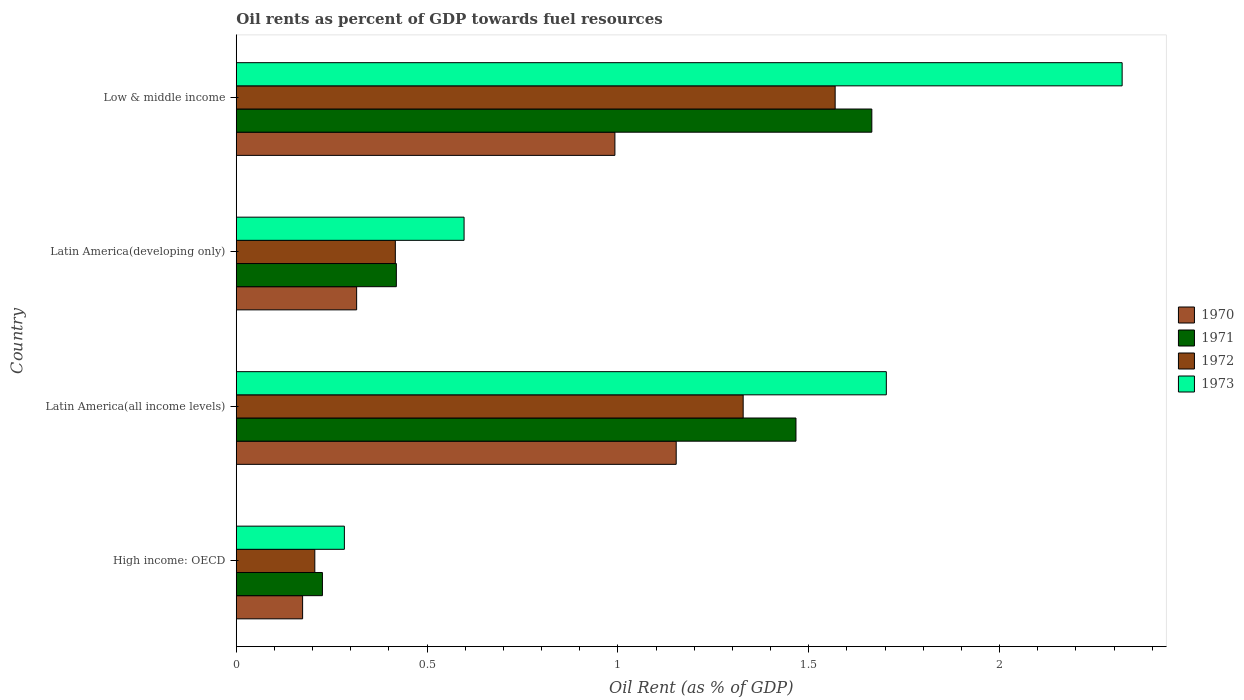How many different coloured bars are there?
Your answer should be very brief. 4. In how many cases, is the number of bars for a given country not equal to the number of legend labels?
Your answer should be very brief. 0. What is the oil rent in 1973 in Latin America(developing only)?
Offer a very short reply. 0.6. Across all countries, what is the maximum oil rent in 1971?
Your answer should be very brief. 1.67. Across all countries, what is the minimum oil rent in 1971?
Provide a succinct answer. 0.23. In which country was the oil rent in 1972 maximum?
Your answer should be compact. Low & middle income. In which country was the oil rent in 1973 minimum?
Ensure brevity in your answer.  High income: OECD. What is the total oil rent in 1972 in the graph?
Offer a very short reply. 3.52. What is the difference between the oil rent in 1972 in Latin America(all income levels) and that in Low & middle income?
Offer a very short reply. -0.24. What is the difference between the oil rent in 1972 in Latin America(all income levels) and the oil rent in 1971 in High income: OECD?
Make the answer very short. 1.1. What is the average oil rent in 1972 per country?
Offer a very short reply. 0.88. What is the difference between the oil rent in 1970 and oil rent in 1972 in Latin America(developing only)?
Make the answer very short. -0.1. In how many countries, is the oil rent in 1972 greater than 0.30000000000000004 %?
Ensure brevity in your answer.  3. What is the ratio of the oil rent in 1971 in High income: OECD to that in Low & middle income?
Provide a succinct answer. 0.14. What is the difference between the highest and the second highest oil rent in 1970?
Your response must be concise. 0.16. What is the difference between the highest and the lowest oil rent in 1970?
Your answer should be compact. 0.98. Is it the case that in every country, the sum of the oil rent in 1973 and oil rent in 1971 is greater than the sum of oil rent in 1970 and oil rent in 1972?
Provide a short and direct response. No. What does the 3rd bar from the top in Low & middle income represents?
Keep it short and to the point. 1971. Is it the case that in every country, the sum of the oil rent in 1971 and oil rent in 1970 is greater than the oil rent in 1973?
Keep it short and to the point. Yes. How many bars are there?
Ensure brevity in your answer.  16. What is the difference between two consecutive major ticks on the X-axis?
Offer a terse response. 0.5. Are the values on the major ticks of X-axis written in scientific E-notation?
Offer a terse response. No. Does the graph contain grids?
Provide a short and direct response. No. How many legend labels are there?
Provide a short and direct response. 4. What is the title of the graph?
Make the answer very short. Oil rents as percent of GDP towards fuel resources. What is the label or title of the X-axis?
Offer a very short reply. Oil Rent (as % of GDP). What is the label or title of the Y-axis?
Your answer should be compact. Country. What is the Oil Rent (as % of GDP) in 1970 in High income: OECD?
Keep it short and to the point. 0.17. What is the Oil Rent (as % of GDP) of 1971 in High income: OECD?
Your response must be concise. 0.23. What is the Oil Rent (as % of GDP) in 1972 in High income: OECD?
Offer a terse response. 0.21. What is the Oil Rent (as % of GDP) in 1973 in High income: OECD?
Provide a short and direct response. 0.28. What is the Oil Rent (as % of GDP) of 1970 in Latin America(all income levels)?
Your answer should be compact. 1.15. What is the Oil Rent (as % of GDP) of 1971 in Latin America(all income levels)?
Ensure brevity in your answer.  1.47. What is the Oil Rent (as % of GDP) of 1972 in Latin America(all income levels)?
Provide a short and direct response. 1.33. What is the Oil Rent (as % of GDP) in 1973 in Latin America(all income levels)?
Provide a succinct answer. 1.7. What is the Oil Rent (as % of GDP) in 1970 in Latin America(developing only)?
Ensure brevity in your answer.  0.32. What is the Oil Rent (as % of GDP) in 1971 in Latin America(developing only)?
Make the answer very short. 0.42. What is the Oil Rent (as % of GDP) in 1972 in Latin America(developing only)?
Your response must be concise. 0.42. What is the Oil Rent (as % of GDP) in 1973 in Latin America(developing only)?
Provide a succinct answer. 0.6. What is the Oil Rent (as % of GDP) in 1970 in Low & middle income?
Give a very brief answer. 0.99. What is the Oil Rent (as % of GDP) in 1971 in Low & middle income?
Offer a terse response. 1.67. What is the Oil Rent (as % of GDP) of 1972 in Low & middle income?
Offer a terse response. 1.57. What is the Oil Rent (as % of GDP) in 1973 in Low & middle income?
Offer a terse response. 2.32. Across all countries, what is the maximum Oil Rent (as % of GDP) of 1970?
Your answer should be very brief. 1.15. Across all countries, what is the maximum Oil Rent (as % of GDP) of 1971?
Offer a very short reply. 1.67. Across all countries, what is the maximum Oil Rent (as % of GDP) of 1972?
Your answer should be compact. 1.57. Across all countries, what is the maximum Oil Rent (as % of GDP) in 1973?
Provide a succinct answer. 2.32. Across all countries, what is the minimum Oil Rent (as % of GDP) in 1970?
Provide a short and direct response. 0.17. Across all countries, what is the minimum Oil Rent (as % of GDP) of 1971?
Offer a terse response. 0.23. Across all countries, what is the minimum Oil Rent (as % of GDP) in 1972?
Your answer should be very brief. 0.21. Across all countries, what is the minimum Oil Rent (as % of GDP) of 1973?
Keep it short and to the point. 0.28. What is the total Oil Rent (as % of GDP) of 1970 in the graph?
Make the answer very short. 2.63. What is the total Oil Rent (as % of GDP) in 1971 in the graph?
Give a very brief answer. 3.78. What is the total Oil Rent (as % of GDP) in 1972 in the graph?
Your answer should be very brief. 3.52. What is the total Oil Rent (as % of GDP) in 1973 in the graph?
Ensure brevity in your answer.  4.9. What is the difference between the Oil Rent (as % of GDP) of 1970 in High income: OECD and that in Latin America(all income levels)?
Offer a terse response. -0.98. What is the difference between the Oil Rent (as % of GDP) of 1971 in High income: OECD and that in Latin America(all income levels)?
Keep it short and to the point. -1.24. What is the difference between the Oil Rent (as % of GDP) of 1972 in High income: OECD and that in Latin America(all income levels)?
Offer a terse response. -1.12. What is the difference between the Oil Rent (as % of GDP) of 1973 in High income: OECD and that in Latin America(all income levels)?
Your answer should be very brief. -1.42. What is the difference between the Oil Rent (as % of GDP) of 1970 in High income: OECD and that in Latin America(developing only)?
Keep it short and to the point. -0.14. What is the difference between the Oil Rent (as % of GDP) in 1971 in High income: OECD and that in Latin America(developing only)?
Ensure brevity in your answer.  -0.19. What is the difference between the Oil Rent (as % of GDP) in 1972 in High income: OECD and that in Latin America(developing only)?
Offer a very short reply. -0.21. What is the difference between the Oil Rent (as % of GDP) in 1973 in High income: OECD and that in Latin America(developing only)?
Provide a succinct answer. -0.31. What is the difference between the Oil Rent (as % of GDP) of 1970 in High income: OECD and that in Low & middle income?
Your answer should be very brief. -0.82. What is the difference between the Oil Rent (as % of GDP) of 1971 in High income: OECD and that in Low & middle income?
Keep it short and to the point. -1.44. What is the difference between the Oil Rent (as % of GDP) in 1972 in High income: OECD and that in Low & middle income?
Provide a succinct answer. -1.36. What is the difference between the Oil Rent (as % of GDP) of 1973 in High income: OECD and that in Low & middle income?
Your response must be concise. -2.04. What is the difference between the Oil Rent (as % of GDP) in 1970 in Latin America(all income levels) and that in Latin America(developing only)?
Offer a very short reply. 0.84. What is the difference between the Oil Rent (as % of GDP) in 1971 in Latin America(all income levels) and that in Latin America(developing only)?
Your answer should be very brief. 1.05. What is the difference between the Oil Rent (as % of GDP) in 1972 in Latin America(all income levels) and that in Latin America(developing only)?
Ensure brevity in your answer.  0.91. What is the difference between the Oil Rent (as % of GDP) in 1973 in Latin America(all income levels) and that in Latin America(developing only)?
Make the answer very short. 1.11. What is the difference between the Oil Rent (as % of GDP) of 1970 in Latin America(all income levels) and that in Low & middle income?
Your answer should be very brief. 0.16. What is the difference between the Oil Rent (as % of GDP) in 1971 in Latin America(all income levels) and that in Low & middle income?
Keep it short and to the point. -0.2. What is the difference between the Oil Rent (as % of GDP) of 1972 in Latin America(all income levels) and that in Low & middle income?
Ensure brevity in your answer.  -0.24. What is the difference between the Oil Rent (as % of GDP) of 1973 in Latin America(all income levels) and that in Low & middle income?
Give a very brief answer. -0.62. What is the difference between the Oil Rent (as % of GDP) of 1970 in Latin America(developing only) and that in Low & middle income?
Make the answer very short. -0.68. What is the difference between the Oil Rent (as % of GDP) in 1971 in Latin America(developing only) and that in Low & middle income?
Offer a terse response. -1.25. What is the difference between the Oil Rent (as % of GDP) of 1972 in Latin America(developing only) and that in Low & middle income?
Your answer should be very brief. -1.15. What is the difference between the Oil Rent (as % of GDP) of 1973 in Latin America(developing only) and that in Low & middle income?
Provide a succinct answer. -1.72. What is the difference between the Oil Rent (as % of GDP) of 1970 in High income: OECD and the Oil Rent (as % of GDP) of 1971 in Latin America(all income levels)?
Keep it short and to the point. -1.29. What is the difference between the Oil Rent (as % of GDP) in 1970 in High income: OECD and the Oil Rent (as % of GDP) in 1972 in Latin America(all income levels)?
Provide a short and direct response. -1.15. What is the difference between the Oil Rent (as % of GDP) of 1970 in High income: OECD and the Oil Rent (as % of GDP) of 1973 in Latin America(all income levels)?
Keep it short and to the point. -1.53. What is the difference between the Oil Rent (as % of GDP) in 1971 in High income: OECD and the Oil Rent (as % of GDP) in 1972 in Latin America(all income levels)?
Your response must be concise. -1.1. What is the difference between the Oil Rent (as % of GDP) in 1971 in High income: OECD and the Oil Rent (as % of GDP) in 1973 in Latin America(all income levels)?
Ensure brevity in your answer.  -1.48. What is the difference between the Oil Rent (as % of GDP) in 1972 in High income: OECD and the Oil Rent (as % of GDP) in 1973 in Latin America(all income levels)?
Give a very brief answer. -1.5. What is the difference between the Oil Rent (as % of GDP) of 1970 in High income: OECD and the Oil Rent (as % of GDP) of 1971 in Latin America(developing only)?
Offer a very short reply. -0.25. What is the difference between the Oil Rent (as % of GDP) in 1970 in High income: OECD and the Oil Rent (as % of GDP) in 1972 in Latin America(developing only)?
Give a very brief answer. -0.24. What is the difference between the Oil Rent (as % of GDP) in 1970 in High income: OECD and the Oil Rent (as % of GDP) in 1973 in Latin America(developing only)?
Make the answer very short. -0.42. What is the difference between the Oil Rent (as % of GDP) in 1971 in High income: OECD and the Oil Rent (as % of GDP) in 1972 in Latin America(developing only)?
Offer a terse response. -0.19. What is the difference between the Oil Rent (as % of GDP) of 1971 in High income: OECD and the Oil Rent (as % of GDP) of 1973 in Latin America(developing only)?
Provide a succinct answer. -0.37. What is the difference between the Oil Rent (as % of GDP) in 1972 in High income: OECD and the Oil Rent (as % of GDP) in 1973 in Latin America(developing only)?
Provide a succinct answer. -0.39. What is the difference between the Oil Rent (as % of GDP) in 1970 in High income: OECD and the Oil Rent (as % of GDP) in 1971 in Low & middle income?
Your answer should be compact. -1.49. What is the difference between the Oil Rent (as % of GDP) of 1970 in High income: OECD and the Oil Rent (as % of GDP) of 1972 in Low & middle income?
Give a very brief answer. -1.4. What is the difference between the Oil Rent (as % of GDP) in 1970 in High income: OECD and the Oil Rent (as % of GDP) in 1973 in Low & middle income?
Ensure brevity in your answer.  -2.15. What is the difference between the Oil Rent (as % of GDP) of 1971 in High income: OECD and the Oil Rent (as % of GDP) of 1972 in Low & middle income?
Your answer should be compact. -1.34. What is the difference between the Oil Rent (as % of GDP) in 1971 in High income: OECD and the Oil Rent (as % of GDP) in 1973 in Low & middle income?
Your answer should be very brief. -2.1. What is the difference between the Oil Rent (as % of GDP) of 1972 in High income: OECD and the Oil Rent (as % of GDP) of 1973 in Low & middle income?
Provide a succinct answer. -2.12. What is the difference between the Oil Rent (as % of GDP) in 1970 in Latin America(all income levels) and the Oil Rent (as % of GDP) in 1971 in Latin America(developing only)?
Keep it short and to the point. 0.73. What is the difference between the Oil Rent (as % of GDP) of 1970 in Latin America(all income levels) and the Oil Rent (as % of GDP) of 1972 in Latin America(developing only)?
Your response must be concise. 0.74. What is the difference between the Oil Rent (as % of GDP) of 1970 in Latin America(all income levels) and the Oil Rent (as % of GDP) of 1973 in Latin America(developing only)?
Provide a short and direct response. 0.56. What is the difference between the Oil Rent (as % of GDP) of 1971 in Latin America(all income levels) and the Oil Rent (as % of GDP) of 1972 in Latin America(developing only)?
Provide a succinct answer. 1.05. What is the difference between the Oil Rent (as % of GDP) in 1971 in Latin America(all income levels) and the Oil Rent (as % of GDP) in 1973 in Latin America(developing only)?
Provide a succinct answer. 0.87. What is the difference between the Oil Rent (as % of GDP) in 1972 in Latin America(all income levels) and the Oil Rent (as % of GDP) in 1973 in Latin America(developing only)?
Your response must be concise. 0.73. What is the difference between the Oil Rent (as % of GDP) in 1970 in Latin America(all income levels) and the Oil Rent (as % of GDP) in 1971 in Low & middle income?
Provide a succinct answer. -0.51. What is the difference between the Oil Rent (as % of GDP) in 1970 in Latin America(all income levels) and the Oil Rent (as % of GDP) in 1972 in Low & middle income?
Offer a terse response. -0.42. What is the difference between the Oil Rent (as % of GDP) of 1970 in Latin America(all income levels) and the Oil Rent (as % of GDP) of 1973 in Low & middle income?
Ensure brevity in your answer.  -1.17. What is the difference between the Oil Rent (as % of GDP) in 1971 in Latin America(all income levels) and the Oil Rent (as % of GDP) in 1972 in Low & middle income?
Ensure brevity in your answer.  -0.1. What is the difference between the Oil Rent (as % of GDP) of 1971 in Latin America(all income levels) and the Oil Rent (as % of GDP) of 1973 in Low & middle income?
Offer a very short reply. -0.85. What is the difference between the Oil Rent (as % of GDP) of 1972 in Latin America(all income levels) and the Oil Rent (as % of GDP) of 1973 in Low & middle income?
Offer a very short reply. -0.99. What is the difference between the Oil Rent (as % of GDP) of 1970 in Latin America(developing only) and the Oil Rent (as % of GDP) of 1971 in Low & middle income?
Make the answer very short. -1.35. What is the difference between the Oil Rent (as % of GDP) of 1970 in Latin America(developing only) and the Oil Rent (as % of GDP) of 1972 in Low & middle income?
Your response must be concise. -1.25. What is the difference between the Oil Rent (as % of GDP) in 1970 in Latin America(developing only) and the Oil Rent (as % of GDP) in 1973 in Low & middle income?
Offer a terse response. -2.01. What is the difference between the Oil Rent (as % of GDP) of 1971 in Latin America(developing only) and the Oil Rent (as % of GDP) of 1972 in Low & middle income?
Provide a succinct answer. -1.15. What is the difference between the Oil Rent (as % of GDP) of 1971 in Latin America(developing only) and the Oil Rent (as % of GDP) of 1973 in Low & middle income?
Your response must be concise. -1.9. What is the difference between the Oil Rent (as % of GDP) of 1972 in Latin America(developing only) and the Oil Rent (as % of GDP) of 1973 in Low & middle income?
Offer a very short reply. -1.9. What is the average Oil Rent (as % of GDP) in 1970 per country?
Your answer should be compact. 0.66. What is the average Oil Rent (as % of GDP) of 1971 per country?
Your answer should be compact. 0.94. What is the average Oil Rent (as % of GDP) in 1973 per country?
Your answer should be very brief. 1.23. What is the difference between the Oil Rent (as % of GDP) in 1970 and Oil Rent (as % of GDP) in 1971 in High income: OECD?
Make the answer very short. -0.05. What is the difference between the Oil Rent (as % of GDP) of 1970 and Oil Rent (as % of GDP) of 1972 in High income: OECD?
Your response must be concise. -0.03. What is the difference between the Oil Rent (as % of GDP) in 1970 and Oil Rent (as % of GDP) in 1973 in High income: OECD?
Your response must be concise. -0.11. What is the difference between the Oil Rent (as % of GDP) of 1971 and Oil Rent (as % of GDP) of 1973 in High income: OECD?
Your answer should be compact. -0.06. What is the difference between the Oil Rent (as % of GDP) in 1972 and Oil Rent (as % of GDP) in 1973 in High income: OECD?
Make the answer very short. -0.08. What is the difference between the Oil Rent (as % of GDP) of 1970 and Oil Rent (as % of GDP) of 1971 in Latin America(all income levels)?
Give a very brief answer. -0.31. What is the difference between the Oil Rent (as % of GDP) of 1970 and Oil Rent (as % of GDP) of 1972 in Latin America(all income levels)?
Your response must be concise. -0.18. What is the difference between the Oil Rent (as % of GDP) in 1970 and Oil Rent (as % of GDP) in 1973 in Latin America(all income levels)?
Provide a succinct answer. -0.55. What is the difference between the Oil Rent (as % of GDP) in 1971 and Oil Rent (as % of GDP) in 1972 in Latin America(all income levels)?
Make the answer very short. 0.14. What is the difference between the Oil Rent (as % of GDP) in 1971 and Oil Rent (as % of GDP) in 1973 in Latin America(all income levels)?
Make the answer very short. -0.24. What is the difference between the Oil Rent (as % of GDP) of 1972 and Oil Rent (as % of GDP) of 1973 in Latin America(all income levels)?
Provide a short and direct response. -0.38. What is the difference between the Oil Rent (as % of GDP) of 1970 and Oil Rent (as % of GDP) of 1971 in Latin America(developing only)?
Your response must be concise. -0.1. What is the difference between the Oil Rent (as % of GDP) in 1970 and Oil Rent (as % of GDP) in 1972 in Latin America(developing only)?
Provide a short and direct response. -0.1. What is the difference between the Oil Rent (as % of GDP) in 1970 and Oil Rent (as % of GDP) in 1973 in Latin America(developing only)?
Your answer should be compact. -0.28. What is the difference between the Oil Rent (as % of GDP) of 1971 and Oil Rent (as % of GDP) of 1972 in Latin America(developing only)?
Offer a very short reply. 0. What is the difference between the Oil Rent (as % of GDP) of 1971 and Oil Rent (as % of GDP) of 1973 in Latin America(developing only)?
Keep it short and to the point. -0.18. What is the difference between the Oil Rent (as % of GDP) in 1972 and Oil Rent (as % of GDP) in 1973 in Latin America(developing only)?
Your response must be concise. -0.18. What is the difference between the Oil Rent (as % of GDP) in 1970 and Oil Rent (as % of GDP) in 1971 in Low & middle income?
Make the answer very short. -0.67. What is the difference between the Oil Rent (as % of GDP) of 1970 and Oil Rent (as % of GDP) of 1972 in Low & middle income?
Your answer should be compact. -0.58. What is the difference between the Oil Rent (as % of GDP) of 1970 and Oil Rent (as % of GDP) of 1973 in Low & middle income?
Make the answer very short. -1.33. What is the difference between the Oil Rent (as % of GDP) of 1971 and Oil Rent (as % of GDP) of 1972 in Low & middle income?
Your answer should be very brief. 0.1. What is the difference between the Oil Rent (as % of GDP) of 1971 and Oil Rent (as % of GDP) of 1973 in Low & middle income?
Your response must be concise. -0.66. What is the difference between the Oil Rent (as % of GDP) in 1972 and Oil Rent (as % of GDP) in 1973 in Low & middle income?
Make the answer very short. -0.75. What is the ratio of the Oil Rent (as % of GDP) in 1970 in High income: OECD to that in Latin America(all income levels)?
Your answer should be very brief. 0.15. What is the ratio of the Oil Rent (as % of GDP) in 1971 in High income: OECD to that in Latin America(all income levels)?
Make the answer very short. 0.15. What is the ratio of the Oil Rent (as % of GDP) of 1972 in High income: OECD to that in Latin America(all income levels)?
Ensure brevity in your answer.  0.15. What is the ratio of the Oil Rent (as % of GDP) in 1973 in High income: OECD to that in Latin America(all income levels)?
Provide a succinct answer. 0.17. What is the ratio of the Oil Rent (as % of GDP) of 1970 in High income: OECD to that in Latin America(developing only)?
Give a very brief answer. 0.55. What is the ratio of the Oil Rent (as % of GDP) in 1971 in High income: OECD to that in Latin America(developing only)?
Provide a short and direct response. 0.54. What is the ratio of the Oil Rent (as % of GDP) in 1972 in High income: OECD to that in Latin America(developing only)?
Your answer should be compact. 0.49. What is the ratio of the Oil Rent (as % of GDP) of 1973 in High income: OECD to that in Latin America(developing only)?
Offer a very short reply. 0.47. What is the ratio of the Oil Rent (as % of GDP) in 1970 in High income: OECD to that in Low & middle income?
Give a very brief answer. 0.18. What is the ratio of the Oil Rent (as % of GDP) in 1971 in High income: OECD to that in Low & middle income?
Provide a succinct answer. 0.14. What is the ratio of the Oil Rent (as % of GDP) in 1972 in High income: OECD to that in Low & middle income?
Ensure brevity in your answer.  0.13. What is the ratio of the Oil Rent (as % of GDP) in 1973 in High income: OECD to that in Low & middle income?
Your response must be concise. 0.12. What is the ratio of the Oil Rent (as % of GDP) of 1970 in Latin America(all income levels) to that in Latin America(developing only)?
Your answer should be very brief. 3.65. What is the ratio of the Oil Rent (as % of GDP) of 1971 in Latin America(all income levels) to that in Latin America(developing only)?
Ensure brevity in your answer.  3.5. What is the ratio of the Oil Rent (as % of GDP) of 1972 in Latin America(all income levels) to that in Latin America(developing only)?
Your answer should be very brief. 3.19. What is the ratio of the Oil Rent (as % of GDP) of 1973 in Latin America(all income levels) to that in Latin America(developing only)?
Your answer should be very brief. 2.85. What is the ratio of the Oil Rent (as % of GDP) of 1970 in Latin America(all income levels) to that in Low & middle income?
Provide a succinct answer. 1.16. What is the ratio of the Oil Rent (as % of GDP) of 1971 in Latin America(all income levels) to that in Low & middle income?
Ensure brevity in your answer.  0.88. What is the ratio of the Oil Rent (as % of GDP) in 1972 in Latin America(all income levels) to that in Low & middle income?
Offer a terse response. 0.85. What is the ratio of the Oil Rent (as % of GDP) in 1973 in Latin America(all income levels) to that in Low & middle income?
Keep it short and to the point. 0.73. What is the ratio of the Oil Rent (as % of GDP) in 1970 in Latin America(developing only) to that in Low & middle income?
Provide a short and direct response. 0.32. What is the ratio of the Oil Rent (as % of GDP) of 1971 in Latin America(developing only) to that in Low & middle income?
Keep it short and to the point. 0.25. What is the ratio of the Oil Rent (as % of GDP) in 1972 in Latin America(developing only) to that in Low & middle income?
Provide a short and direct response. 0.27. What is the ratio of the Oil Rent (as % of GDP) in 1973 in Latin America(developing only) to that in Low & middle income?
Offer a terse response. 0.26. What is the difference between the highest and the second highest Oil Rent (as % of GDP) in 1970?
Ensure brevity in your answer.  0.16. What is the difference between the highest and the second highest Oil Rent (as % of GDP) of 1971?
Offer a terse response. 0.2. What is the difference between the highest and the second highest Oil Rent (as % of GDP) in 1972?
Keep it short and to the point. 0.24. What is the difference between the highest and the second highest Oil Rent (as % of GDP) of 1973?
Offer a terse response. 0.62. What is the difference between the highest and the lowest Oil Rent (as % of GDP) of 1970?
Keep it short and to the point. 0.98. What is the difference between the highest and the lowest Oil Rent (as % of GDP) in 1971?
Provide a succinct answer. 1.44. What is the difference between the highest and the lowest Oil Rent (as % of GDP) in 1972?
Offer a very short reply. 1.36. What is the difference between the highest and the lowest Oil Rent (as % of GDP) of 1973?
Ensure brevity in your answer.  2.04. 